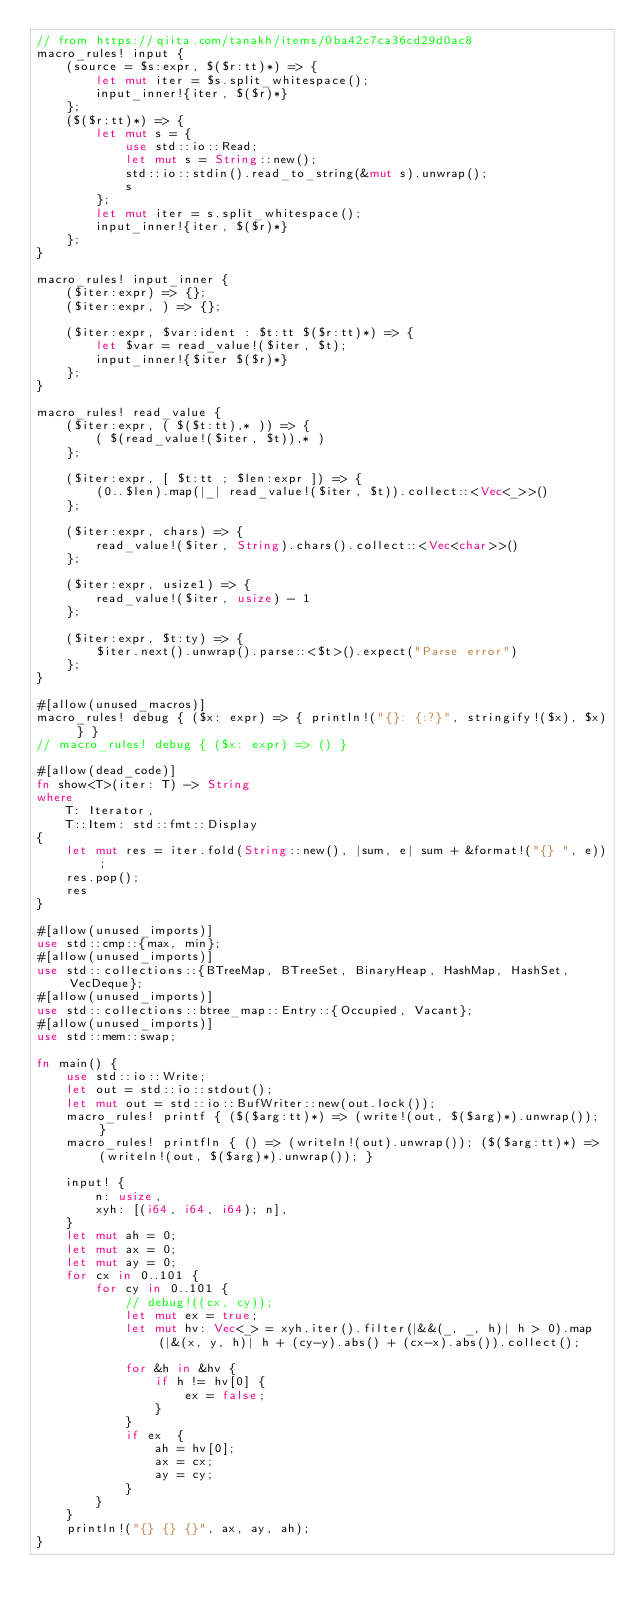<code> <loc_0><loc_0><loc_500><loc_500><_Rust_>// from https://qiita.com/tanakh/items/0ba42c7ca36cd29d0ac8
macro_rules! input {
    (source = $s:expr, $($r:tt)*) => {
        let mut iter = $s.split_whitespace();
        input_inner!{iter, $($r)*}
    };
    ($($r:tt)*) => {
        let mut s = {
            use std::io::Read;
            let mut s = String::new();
            std::io::stdin().read_to_string(&mut s).unwrap();
            s
        };
        let mut iter = s.split_whitespace();
        input_inner!{iter, $($r)*}
    };
}

macro_rules! input_inner {
    ($iter:expr) => {};
    ($iter:expr, ) => {};

    ($iter:expr, $var:ident : $t:tt $($r:tt)*) => {
        let $var = read_value!($iter, $t);
        input_inner!{$iter $($r)*}
    };
}

macro_rules! read_value {
    ($iter:expr, ( $($t:tt),* )) => {
        ( $(read_value!($iter, $t)),* )
    };

    ($iter:expr, [ $t:tt ; $len:expr ]) => {
        (0..$len).map(|_| read_value!($iter, $t)).collect::<Vec<_>>()
    };

    ($iter:expr, chars) => {
        read_value!($iter, String).chars().collect::<Vec<char>>()
    };

    ($iter:expr, usize1) => {
        read_value!($iter, usize) - 1
    };

    ($iter:expr, $t:ty) => {
        $iter.next().unwrap().parse::<$t>().expect("Parse error")
    };
}

#[allow(unused_macros)]
macro_rules! debug { ($x: expr) => { println!("{}: {:?}", stringify!($x), $x) } }
// macro_rules! debug { ($x: expr) => () }

#[allow(dead_code)]
fn show<T>(iter: T) -> String
where
    T: Iterator,
    T::Item: std::fmt::Display
{
    let mut res = iter.fold(String::new(), |sum, e| sum + &format!("{} ", e));
    res.pop();
    res
}

#[allow(unused_imports)]
use std::cmp::{max, min};
#[allow(unused_imports)]
use std::collections::{BTreeMap, BTreeSet, BinaryHeap, HashMap, HashSet, VecDeque};
#[allow(unused_imports)]
use std::collections::btree_map::Entry::{Occupied, Vacant};
#[allow(unused_imports)]
use std::mem::swap;

fn main() {
    use std::io::Write;
    let out = std::io::stdout();
    let mut out = std::io::BufWriter::new(out.lock());
    macro_rules! printf { ($($arg:tt)*) => (write!(out, $($arg)*).unwrap()); }
    macro_rules! printfln { () => (writeln!(out).unwrap()); ($($arg:tt)*) => (writeln!(out, $($arg)*).unwrap()); }
    
    input! {
        n: usize,
        xyh: [(i64, i64, i64); n],
    }
    let mut ah = 0;
    let mut ax = 0;
    let mut ay = 0;
    for cx in 0..101 {
        for cy in 0..101 {
            // debug!((cx, cy));
            let mut ex = true;
            let mut hv: Vec<_> = xyh.iter().filter(|&&(_, _, h)| h > 0).map(|&(x, y, h)| h + (cy-y).abs() + (cx-x).abs()).collect();

            for &h in &hv {
                if h != hv[0] {
                    ex = false;
                } 
            }
            if ex  {
                ah = hv[0];
                ax = cx;
                ay = cy;
            }
        }
    }
    println!("{} {} {}", ax, ay, ah);
}
</code> 